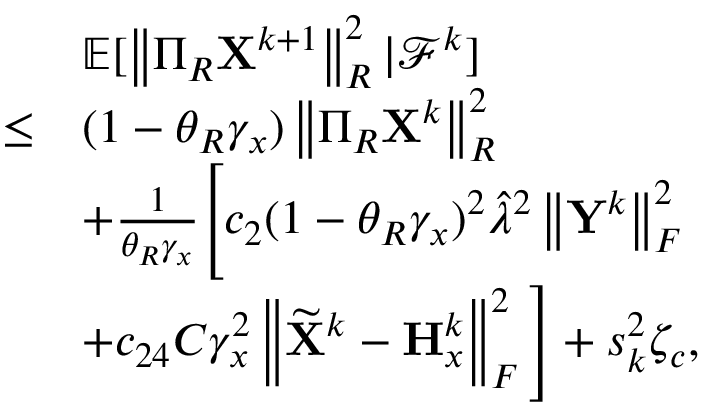Convert formula to latex. <formula><loc_0><loc_0><loc_500><loc_500>\begin{array} { r l } & { { \mathbb { E } } [ \left \| \Pi _ { R } { X } ^ { k + 1 } \right \| _ { R } ^ { 2 } | { \mathcal { F } } ^ { k } ] } \\ { \leq } & { ( 1 - \theta _ { R } \gamma _ { x } ) \left \| \Pi _ { R } { X } ^ { k } \right \| _ { R } ^ { 2 } } \\ & { + \frac { 1 } { \theta _ { R } \gamma _ { x } } \left [ c _ { 2 } ( 1 - \theta _ { R } \gamma _ { x } ) ^ { 2 } \hat { \lambda } ^ { 2 } \left \| { Y } ^ { k } \right \| _ { F } ^ { 2 } } \\ & { + c _ { 2 4 } C \gamma _ { x } ^ { 2 } \left \| \widetilde { X } ^ { k } - { H } _ { x } ^ { k } \right \| _ { F } ^ { 2 } \right ] + s _ { k } ^ { 2 } \zeta _ { c } , } \end{array}</formula> 